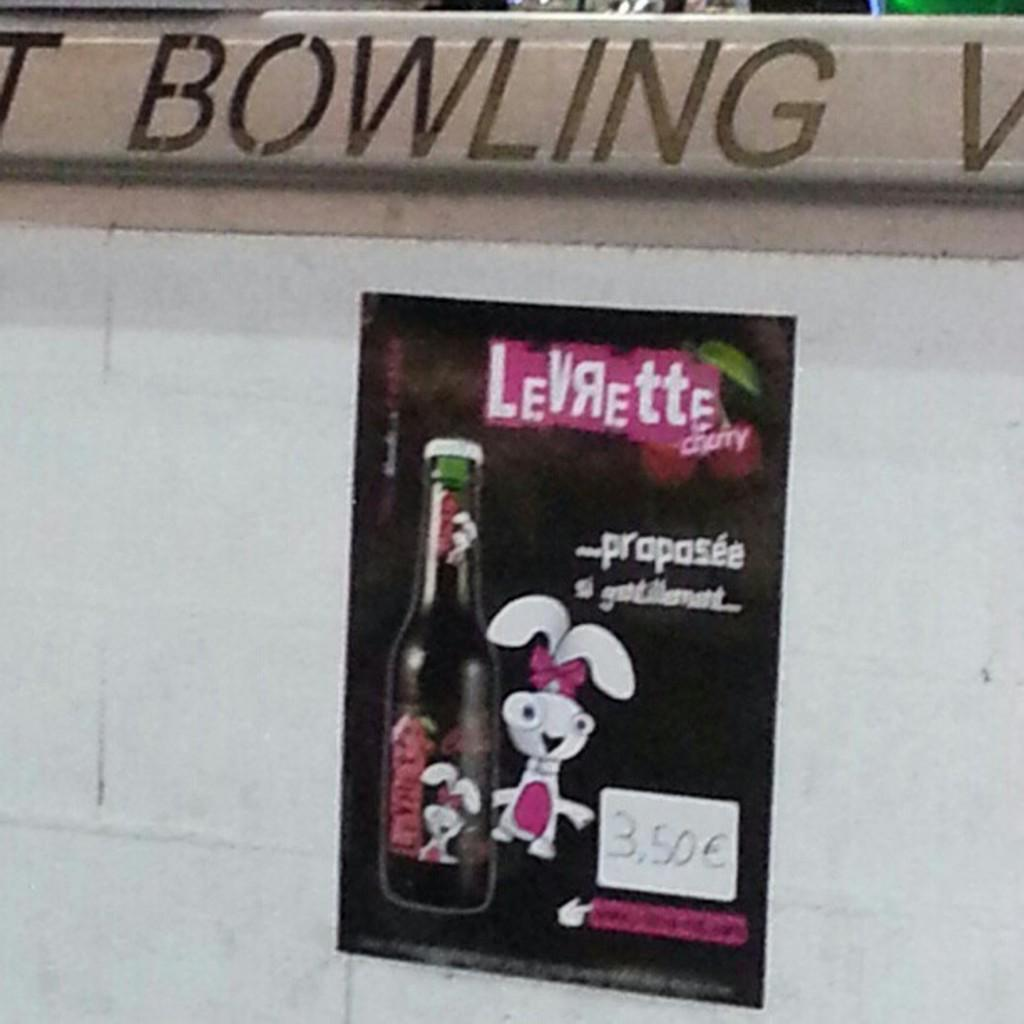Provide a one-sentence caption for the provided image. A Levrette sticker on a wall at a bowling alley. 